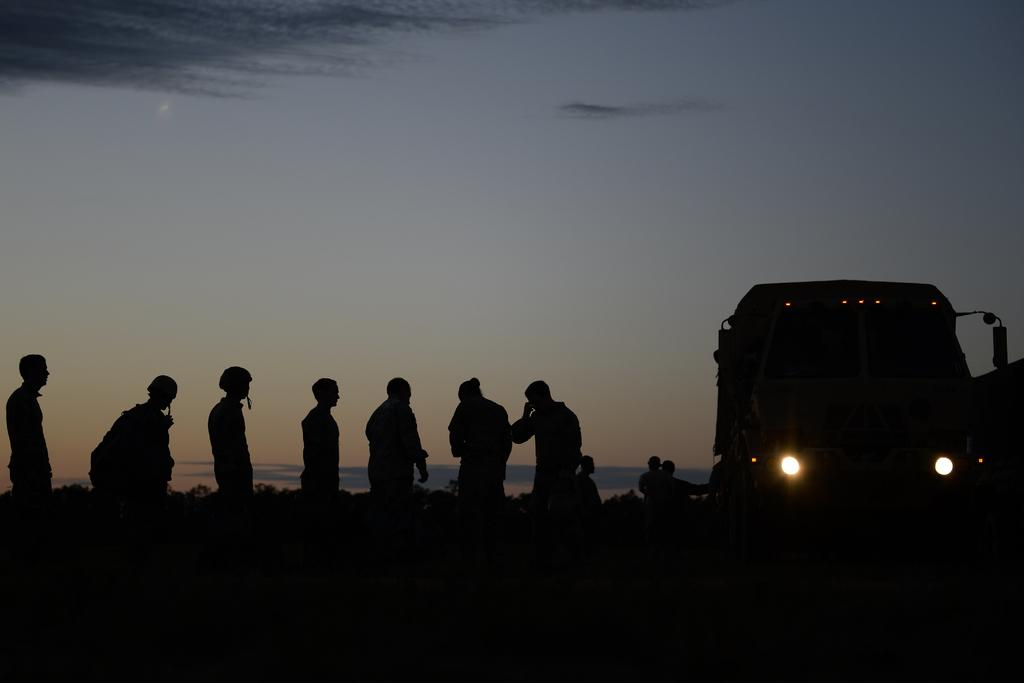What is the main subject in the center of the image? There are persons in the center of the image. What else can be seen on the right side of the image? There is a vehicle on the right side of the image. What type of natural elements are visible in the background of the image? There are plants visible in the background of the image. What is visible at the top of the image? The sky is visible at the top of the image. Reasoning: Let' Let's think step by step in order to produce the conversation. We start by identifying the main subjects and objects in the image based on the provided facts. We then formulate questions that focus on the location and characteristics of these subjects and objects, ensuring that each question can be answered definitively with the information given. We avoid yes/no questions and ensure that the language is simple and clear. Absurd Question/Answer: What type of potato is being used as a stocking in the image? There is no potato or stocking present in the image. Can you describe the argument taking place between the persons in the image? There is no argument depicted in the image; the persons are not engaged in any conflict. 